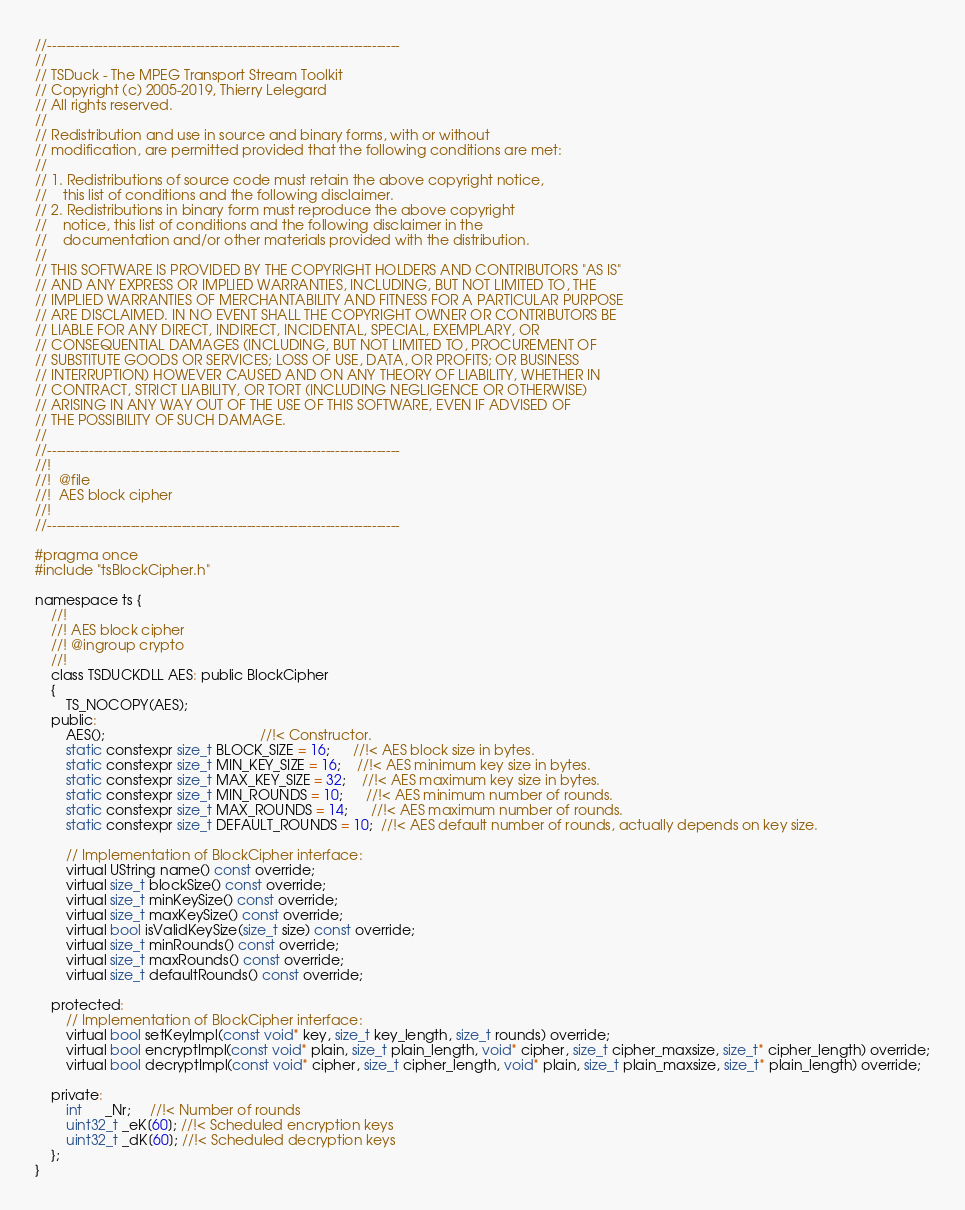<code> <loc_0><loc_0><loc_500><loc_500><_C_>//----------------------------------------------------------------------------
//
// TSDuck - The MPEG Transport Stream Toolkit
// Copyright (c) 2005-2019, Thierry Lelegard
// All rights reserved.
//
// Redistribution and use in source and binary forms, with or without
// modification, are permitted provided that the following conditions are met:
//
// 1. Redistributions of source code must retain the above copyright notice,
//    this list of conditions and the following disclaimer.
// 2. Redistributions in binary form must reproduce the above copyright
//    notice, this list of conditions and the following disclaimer in the
//    documentation and/or other materials provided with the distribution.
//
// THIS SOFTWARE IS PROVIDED BY THE COPYRIGHT HOLDERS AND CONTRIBUTORS "AS IS"
// AND ANY EXPRESS OR IMPLIED WARRANTIES, INCLUDING, BUT NOT LIMITED TO, THE
// IMPLIED WARRANTIES OF MERCHANTABILITY AND FITNESS FOR A PARTICULAR PURPOSE
// ARE DISCLAIMED. IN NO EVENT SHALL THE COPYRIGHT OWNER OR CONTRIBUTORS BE
// LIABLE FOR ANY DIRECT, INDIRECT, INCIDENTAL, SPECIAL, EXEMPLARY, OR
// CONSEQUENTIAL DAMAGES (INCLUDING, BUT NOT LIMITED TO, PROCUREMENT OF
// SUBSTITUTE GOODS OR SERVICES; LOSS OF USE, DATA, OR PROFITS; OR BUSINESS
// INTERRUPTION) HOWEVER CAUSED AND ON ANY THEORY OF LIABILITY, WHETHER IN
// CONTRACT, STRICT LIABILITY, OR TORT (INCLUDING NEGLIGENCE OR OTHERWISE)
// ARISING IN ANY WAY OUT OF THE USE OF THIS SOFTWARE, EVEN IF ADVISED OF
// THE POSSIBILITY OF SUCH DAMAGE.
//
//----------------------------------------------------------------------------
//!
//!  @file
//!  AES block cipher
//!
//----------------------------------------------------------------------------

#pragma once
#include "tsBlockCipher.h"

namespace ts {
    //!
    //! AES block cipher
    //! @ingroup crypto
    //!
    class TSDUCKDLL AES: public BlockCipher
    {
        TS_NOCOPY(AES);
    public:
        AES();                                        //!< Constructor.
        static constexpr size_t BLOCK_SIZE = 16;      //!< AES block size in bytes.
        static constexpr size_t MIN_KEY_SIZE = 16;    //!< AES minimum key size in bytes.
        static constexpr size_t MAX_KEY_SIZE = 32;    //!< AES maximum key size in bytes.
        static constexpr size_t MIN_ROUNDS = 10;      //!< AES minimum number of rounds.
        static constexpr size_t MAX_ROUNDS = 14;      //!< AES maximum number of rounds.
        static constexpr size_t DEFAULT_ROUNDS = 10;  //!< AES default number of rounds, actually depends on key size.

        // Implementation of BlockCipher interface:
        virtual UString name() const override;
        virtual size_t blockSize() const override;
        virtual size_t minKeySize() const override;
        virtual size_t maxKeySize() const override;
        virtual bool isValidKeySize(size_t size) const override;
        virtual size_t minRounds() const override;
        virtual size_t maxRounds() const override;
        virtual size_t defaultRounds() const override;

    protected:
        // Implementation of BlockCipher interface:
        virtual bool setKeyImpl(const void* key, size_t key_length, size_t rounds) override;
        virtual bool encryptImpl(const void* plain, size_t plain_length, void* cipher, size_t cipher_maxsize, size_t* cipher_length) override;
        virtual bool decryptImpl(const void* cipher, size_t cipher_length, void* plain, size_t plain_maxsize, size_t* plain_length) override;

    private:
        int      _Nr;     //!< Number of rounds
        uint32_t _eK[60]; //!< Scheduled encryption keys
        uint32_t _dK[60]; //!< Scheduled decryption keys
    };
}
</code> 